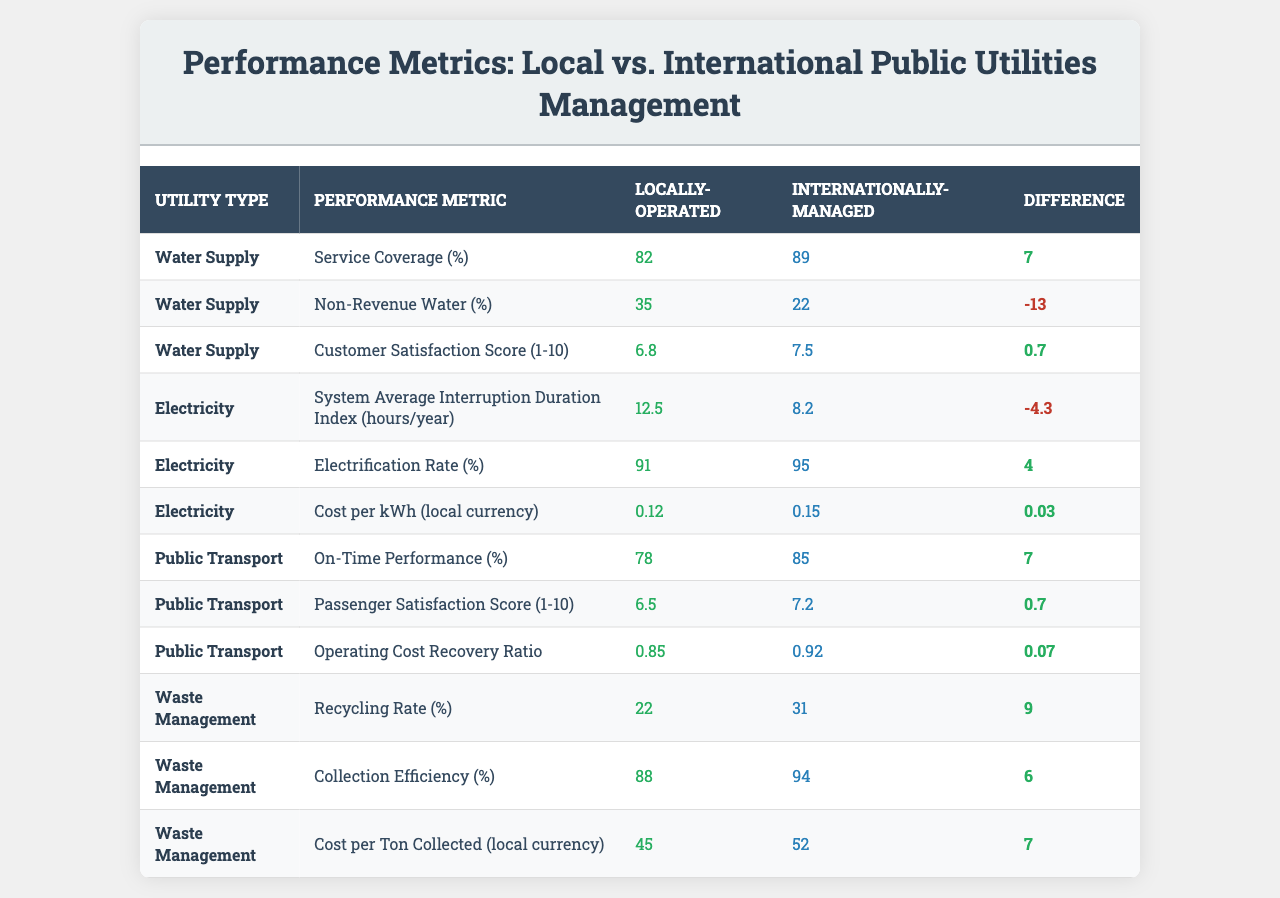What is the service coverage percentage for locally-operated water supply? According to the table, the service coverage percentage for locally-operated water supply is shown directly in the corresponding cell. It reads 82%.
Answer: 82% What is the customer satisfaction score for internationally-managed public transport? The table indicates the customer satisfaction score for internationally-managed public transport, which is 7.2 out of 10.
Answer: 7.2 Is the non-revenue water percentage higher for locally-operated or internationally-managed water supply? By comparing the non-revenue water percentages in the table, locally-operated water supply has 35%, while internationally-managed has 22%. Since 35% is greater than 22%, it is higher for locally-operated.
Answer: Locally-operated What is the percentage difference in on-time performance between locally-operated and internationally-managed public transport? The on-time performance for locally-operated is 78%, and for internationally-managed, it is 85%. The difference can be calculated as 85 - 78 = 7%.
Answer: 7% Which utility type has the highest electrification rate, and what is that percentage? The table shows electrification rates for both utility types. The locally-operated electrification rate is 91%, while internationally-managed is 95%. The highest is internationally-managed at 95%.
Answer: Internationally-managed, 95% What is the average cost per unit for locally-operated utilities? To find the average cost per unit for locally-operated utilities, we have to look at the costs listed: for electricity, it is 0.12, for public transport we have no data on cost per unit, and for waste management, it's 45. Only electricity and waste management can be averaged. (0.12 + 45)/2 = 22.56.
Answer: 22.56 If the non-revenue water decreases by 5% in internationally-managed water supply, what would its new percentage be? The initial non-revenue water percentage for internationally-managed water supply is 22%. If it decreases by 5%, we subtract: 22 - 5 = 17%.
Answer: 17% Which utility has the lowest recycling rate and what is that percentage? According to the table, the recycling rate for locally-operated waste management is 22%, while internationally-managed is 31%. Thus, the lowest recycling rate is for locally-operated waste management.
Answer: 22% What is the difference in customer satisfaction between locally-operated and internationally-managed water supply? The customer satisfaction score for locally-operated water supply is 6.8, while for internationally-managed it is 7.5. The difference is calculated as 7.5 - 6.8 = 0.7.
Answer: 0.7 Can it be concluded that internationally-managed public utilities perform better in terms of customer satisfaction based on the provided data? By examining the customer satisfaction scores, internationally-managed public utilities have higher scores (7.5) compared to locally-operated ones (6.8). Therefore, it can be concluded they perform better in this regard.
Answer: Yes 